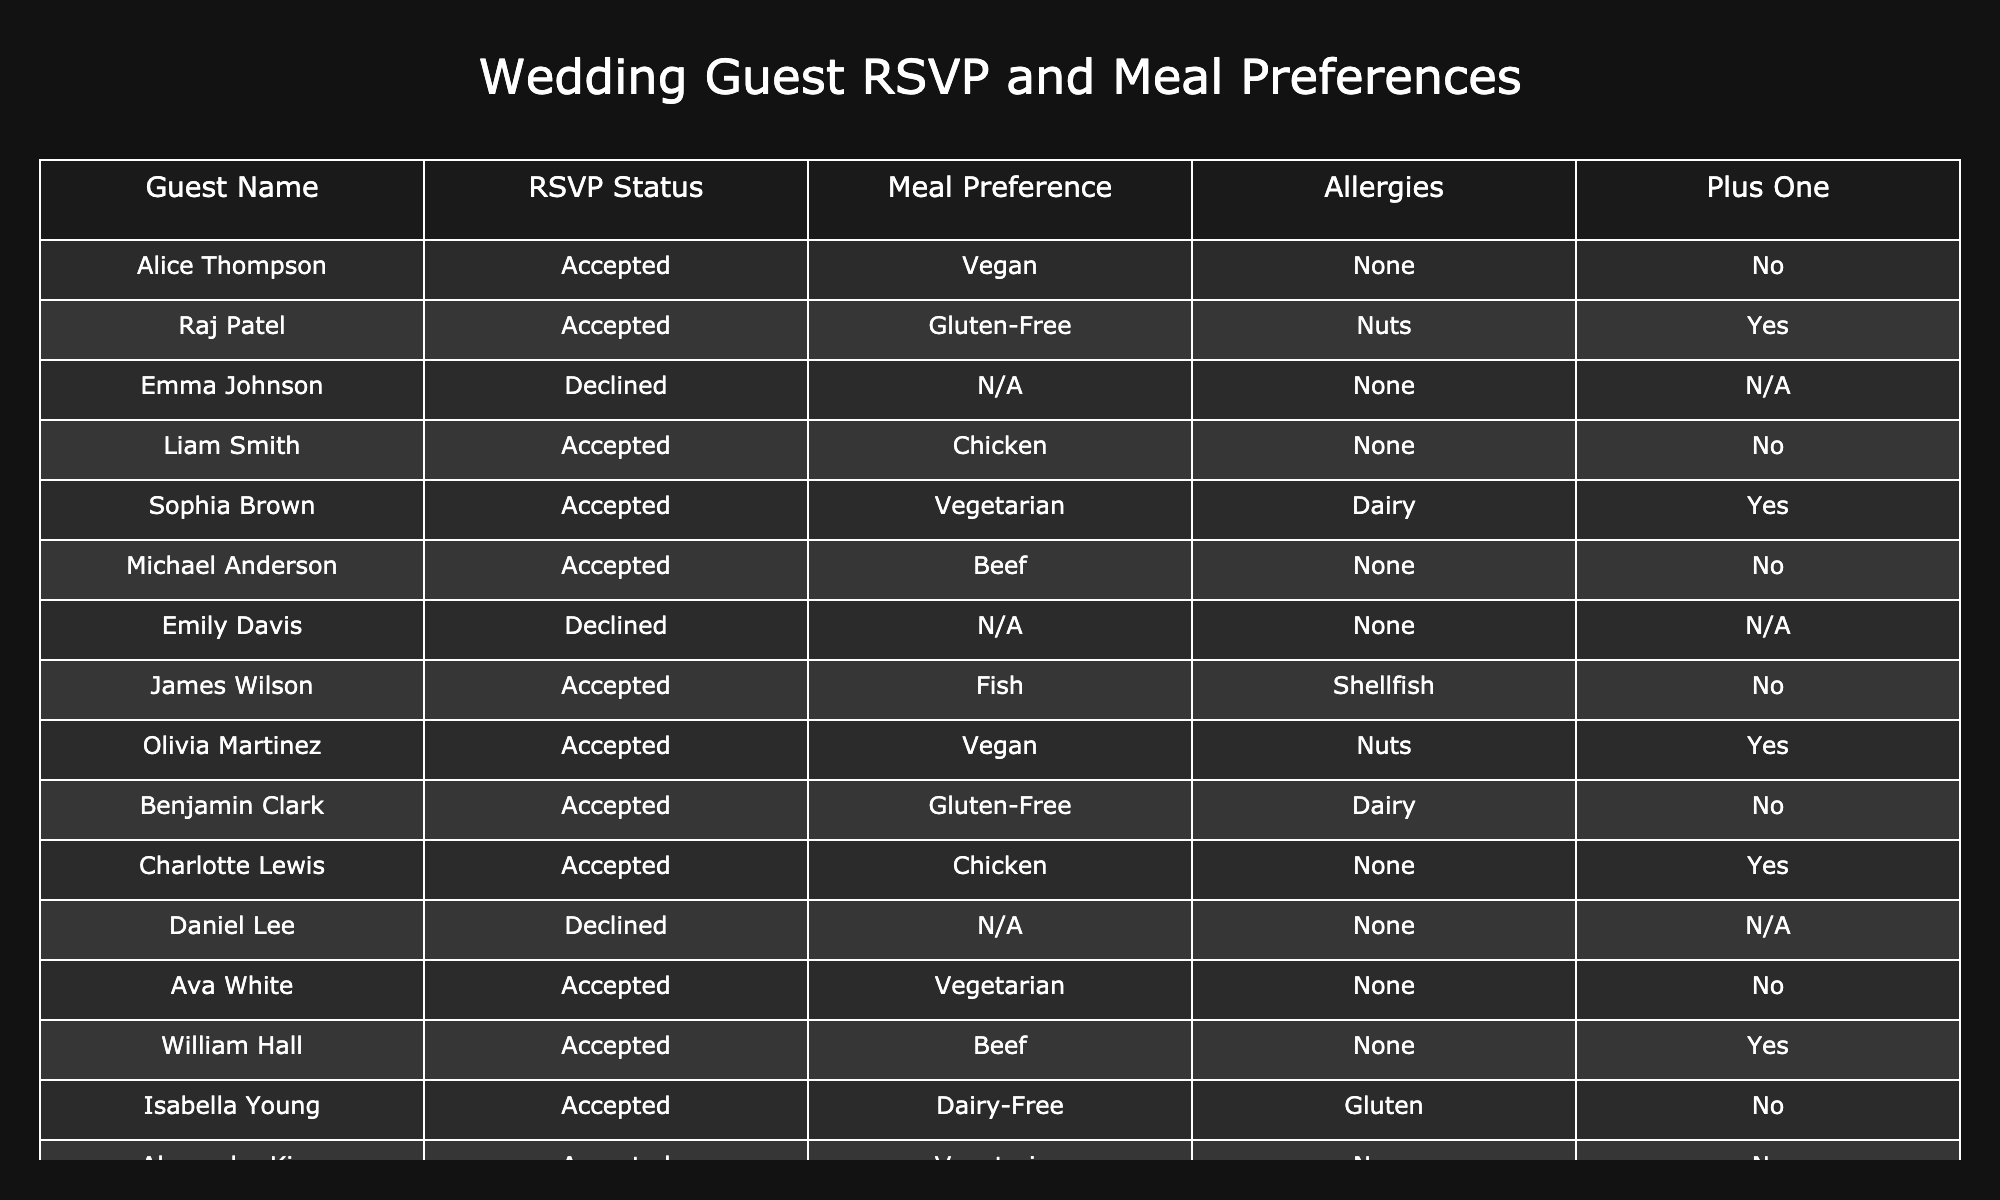What is the meal preference of Alice Thompson? Alice Thompson's meal preference is listed under the 'Meal Preference' column, and for her, it is 'Vegan'.
Answer: Vegan How many guests accepted the RSVP? By counting the entries in the 'RSVP Status' column that say 'Accepted', we find there are 10 guests who accepted.
Answer: 10 Are there any guests who have allergies? Checking the 'Allergies' column, we see that only Raj Patel, Sophia Brown, James Wilson, and Isabella Young have allergies listed. Thus, there are guests with allergies.
Answer: Yes What meal preference is the most common among the accepted guests? To find the most common meal preference among the accepted guests, we summarize the 'Meal Preference' column for entries marked 'Accepted'. It shows Vegan, Gluten-Free, Chicken, Vegetarian, Beef, Fish, and Dairy-Free. Since Chicken and Vegetarian appear twice, they are the most common.
Answer: Chicken and Vegetarian How many guests prefer a meal that is not meat-based (vegetarian, vegan, or gluten-free)? We will filter through the 'Meal Preference' column and count the entries that are Vegetarian, Vegan, or Gluten-Free. The total counts are 5 guests (Alice Thompson, Sophia Brown, Olivia Martinez, Ava White, and Benjamin Clark).
Answer: 5 Is there any guest who accepted the RSVP and has a Plus One? By checking the 'Plus One' column for guests whose RSVP is 'Accepted', we see that Raj Patel, Sophia Brown, Charlotte Lewis, and William Hall have a Plus One. This confirms that there are guests with a Plus One.
Answer: Yes What percentage of accepted guests have gluten-free meal preferences? There are a total of 10 accepted guests, among which 2 have gluten-free meal preferences (Raj Patel and Benjamin Clark). Therefore, the percentage is calculated as (2/10) * 100 = 20%.
Answer: 20% How many guests declined their RSVP and have meal preferences listed? Both Emily Davis and Daniel Lee declined and do not have meal preferences listed; thus, the count of declined guests with preferences is zero.
Answer: 0 Which guests prefer fish or beef? Looking into the 'Meal Preference' column, Michael Anderson (Beef) and James Wilson (Fish) prefer either of these meals.
Answer: Michael Anderson and James Wilson 